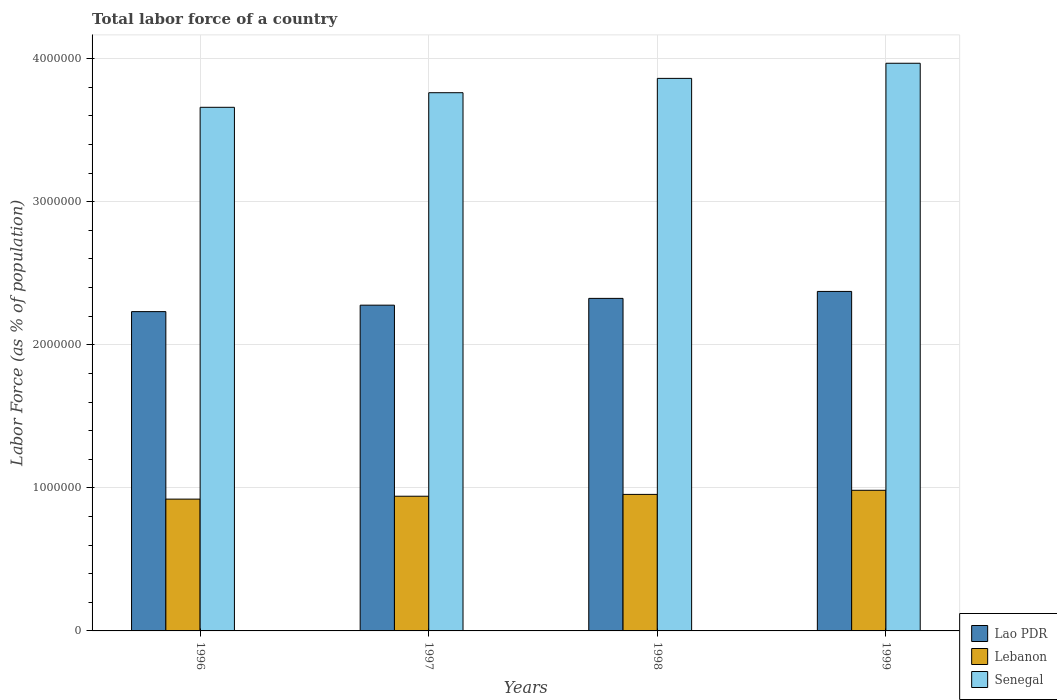How many different coloured bars are there?
Offer a very short reply. 3. How many groups of bars are there?
Offer a terse response. 4. Are the number of bars per tick equal to the number of legend labels?
Offer a very short reply. Yes. Are the number of bars on each tick of the X-axis equal?
Your answer should be very brief. Yes. How many bars are there on the 2nd tick from the right?
Give a very brief answer. 3. What is the label of the 4th group of bars from the left?
Keep it short and to the point. 1999. In how many cases, is the number of bars for a given year not equal to the number of legend labels?
Ensure brevity in your answer.  0. What is the percentage of labor force in Lebanon in 1997?
Give a very brief answer. 9.42e+05. Across all years, what is the maximum percentage of labor force in Lao PDR?
Your response must be concise. 2.37e+06. Across all years, what is the minimum percentage of labor force in Senegal?
Offer a terse response. 3.66e+06. In which year was the percentage of labor force in Lao PDR minimum?
Your response must be concise. 1996. What is the total percentage of labor force in Senegal in the graph?
Your answer should be compact. 1.53e+07. What is the difference between the percentage of labor force in Lebanon in 1996 and that in 1999?
Your answer should be very brief. -6.17e+04. What is the difference between the percentage of labor force in Senegal in 1998 and the percentage of labor force in Lao PDR in 1996?
Make the answer very short. 1.63e+06. What is the average percentage of labor force in Lao PDR per year?
Offer a very short reply. 2.30e+06. In the year 1997, what is the difference between the percentage of labor force in Lebanon and percentage of labor force in Lao PDR?
Ensure brevity in your answer.  -1.34e+06. What is the ratio of the percentage of labor force in Lebanon in 1997 to that in 1998?
Ensure brevity in your answer.  0.99. Is the difference between the percentage of labor force in Lebanon in 1997 and 1998 greater than the difference between the percentage of labor force in Lao PDR in 1997 and 1998?
Offer a terse response. Yes. What is the difference between the highest and the second highest percentage of labor force in Senegal?
Provide a succinct answer. 1.06e+05. What is the difference between the highest and the lowest percentage of labor force in Lebanon?
Provide a short and direct response. 6.17e+04. What does the 2nd bar from the left in 1996 represents?
Your answer should be very brief. Lebanon. What does the 3rd bar from the right in 1996 represents?
Give a very brief answer. Lao PDR. How many bars are there?
Your response must be concise. 12. Are all the bars in the graph horizontal?
Give a very brief answer. No. What is the difference between two consecutive major ticks on the Y-axis?
Offer a terse response. 1.00e+06. Are the values on the major ticks of Y-axis written in scientific E-notation?
Offer a very short reply. No. Does the graph contain any zero values?
Make the answer very short. No. Does the graph contain grids?
Provide a short and direct response. Yes. How many legend labels are there?
Ensure brevity in your answer.  3. What is the title of the graph?
Provide a short and direct response. Total labor force of a country. What is the label or title of the Y-axis?
Ensure brevity in your answer.  Labor Force (as % of population). What is the Labor Force (as % of population) of Lao PDR in 1996?
Ensure brevity in your answer.  2.23e+06. What is the Labor Force (as % of population) in Lebanon in 1996?
Offer a very short reply. 9.21e+05. What is the Labor Force (as % of population) of Senegal in 1996?
Your answer should be very brief. 3.66e+06. What is the Labor Force (as % of population) of Lao PDR in 1997?
Give a very brief answer. 2.28e+06. What is the Labor Force (as % of population) of Lebanon in 1997?
Your answer should be compact. 9.42e+05. What is the Labor Force (as % of population) in Senegal in 1997?
Your answer should be very brief. 3.76e+06. What is the Labor Force (as % of population) of Lao PDR in 1998?
Your answer should be compact. 2.32e+06. What is the Labor Force (as % of population) in Lebanon in 1998?
Your response must be concise. 9.54e+05. What is the Labor Force (as % of population) of Senegal in 1998?
Provide a short and direct response. 3.86e+06. What is the Labor Force (as % of population) of Lao PDR in 1999?
Your answer should be very brief. 2.37e+06. What is the Labor Force (as % of population) in Lebanon in 1999?
Your answer should be compact. 9.83e+05. What is the Labor Force (as % of population) of Senegal in 1999?
Your answer should be very brief. 3.97e+06. Across all years, what is the maximum Labor Force (as % of population) in Lao PDR?
Provide a succinct answer. 2.37e+06. Across all years, what is the maximum Labor Force (as % of population) of Lebanon?
Offer a terse response. 9.83e+05. Across all years, what is the maximum Labor Force (as % of population) in Senegal?
Offer a very short reply. 3.97e+06. Across all years, what is the minimum Labor Force (as % of population) in Lao PDR?
Your response must be concise. 2.23e+06. Across all years, what is the minimum Labor Force (as % of population) in Lebanon?
Your answer should be very brief. 9.21e+05. Across all years, what is the minimum Labor Force (as % of population) of Senegal?
Make the answer very short. 3.66e+06. What is the total Labor Force (as % of population) in Lao PDR in the graph?
Your answer should be compact. 9.21e+06. What is the total Labor Force (as % of population) of Lebanon in the graph?
Provide a succinct answer. 3.80e+06. What is the total Labor Force (as % of population) in Senegal in the graph?
Provide a short and direct response. 1.53e+07. What is the difference between the Labor Force (as % of population) of Lao PDR in 1996 and that in 1997?
Provide a succinct answer. -4.51e+04. What is the difference between the Labor Force (as % of population) in Lebanon in 1996 and that in 1997?
Offer a terse response. -2.01e+04. What is the difference between the Labor Force (as % of population) of Senegal in 1996 and that in 1997?
Your response must be concise. -1.02e+05. What is the difference between the Labor Force (as % of population) in Lao PDR in 1996 and that in 1998?
Your answer should be very brief. -9.25e+04. What is the difference between the Labor Force (as % of population) of Lebanon in 1996 and that in 1998?
Ensure brevity in your answer.  -3.30e+04. What is the difference between the Labor Force (as % of population) of Senegal in 1996 and that in 1998?
Offer a terse response. -2.02e+05. What is the difference between the Labor Force (as % of population) of Lao PDR in 1996 and that in 1999?
Offer a very short reply. -1.41e+05. What is the difference between the Labor Force (as % of population) in Lebanon in 1996 and that in 1999?
Give a very brief answer. -6.17e+04. What is the difference between the Labor Force (as % of population) of Senegal in 1996 and that in 1999?
Give a very brief answer. -3.08e+05. What is the difference between the Labor Force (as % of population) in Lao PDR in 1997 and that in 1998?
Give a very brief answer. -4.74e+04. What is the difference between the Labor Force (as % of population) in Lebanon in 1997 and that in 1998?
Your response must be concise. -1.28e+04. What is the difference between the Labor Force (as % of population) of Senegal in 1997 and that in 1998?
Ensure brevity in your answer.  -1.00e+05. What is the difference between the Labor Force (as % of population) of Lao PDR in 1997 and that in 1999?
Offer a terse response. -9.60e+04. What is the difference between the Labor Force (as % of population) in Lebanon in 1997 and that in 1999?
Offer a very short reply. -4.16e+04. What is the difference between the Labor Force (as % of population) of Senegal in 1997 and that in 1999?
Provide a short and direct response. -2.06e+05. What is the difference between the Labor Force (as % of population) in Lao PDR in 1998 and that in 1999?
Offer a very short reply. -4.86e+04. What is the difference between the Labor Force (as % of population) of Lebanon in 1998 and that in 1999?
Offer a very short reply. -2.87e+04. What is the difference between the Labor Force (as % of population) of Senegal in 1998 and that in 1999?
Your answer should be compact. -1.06e+05. What is the difference between the Labor Force (as % of population) in Lao PDR in 1996 and the Labor Force (as % of population) in Lebanon in 1997?
Give a very brief answer. 1.29e+06. What is the difference between the Labor Force (as % of population) of Lao PDR in 1996 and the Labor Force (as % of population) of Senegal in 1997?
Your answer should be compact. -1.53e+06. What is the difference between the Labor Force (as % of population) in Lebanon in 1996 and the Labor Force (as % of population) in Senegal in 1997?
Ensure brevity in your answer.  -2.84e+06. What is the difference between the Labor Force (as % of population) of Lao PDR in 1996 and the Labor Force (as % of population) of Lebanon in 1998?
Give a very brief answer. 1.28e+06. What is the difference between the Labor Force (as % of population) of Lao PDR in 1996 and the Labor Force (as % of population) of Senegal in 1998?
Ensure brevity in your answer.  -1.63e+06. What is the difference between the Labor Force (as % of population) of Lebanon in 1996 and the Labor Force (as % of population) of Senegal in 1998?
Offer a very short reply. -2.94e+06. What is the difference between the Labor Force (as % of population) in Lao PDR in 1996 and the Labor Force (as % of population) in Lebanon in 1999?
Your response must be concise. 1.25e+06. What is the difference between the Labor Force (as % of population) of Lao PDR in 1996 and the Labor Force (as % of population) of Senegal in 1999?
Offer a terse response. -1.74e+06. What is the difference between the Labor Force (as % of population) in Lebanon in 1996 and the Labor Force (as % of population) in Senegal in 1999?
Offer a terse response. -3.05e+06. What is the difference between the Labor Force (as % of population) of Lao PDR in 1997 and the Labor Force (as % of population) of Lebanon in 1998?
Offer a very short reply. 1.32e+06. What is the difference between the Labor Force (as % of population) of Lao PDR in 1997 and the Labor Force (as % of population) of Senegal in 1998?
Your answer should be compact. -1.59e+06. What is the difference between the Labor Force (as % of population) of Lebanon in 1997 and the Labor Force (as % of population) of Senegal in 1998?
Make the answer very short. -2.92e+06. What is the difference between the Labor Force (as % of population) in Lao PDR in 1997 and the Labor Force (as % of population) in Lebanon in 1999?
Your answer should be very brief. 1.29e+06. What is the difference between the Labor Force (as % of population) in Lao PDR in 1997 and the Labor Force (as % of population) in Senegal in 1999?
Your response must be concise. -1.69e+06. What is the difference between the Labor Force (as % of population) of Lebanon in 1997 and the Labor Force (as % of population) of Senegal in 1999?
Your response must be concise. -3.03e+06. What is the difference between the Labor Force (as % of population) of Lao PDR in 1998 and the Labor Force (as % of population) of Lebanon in 1999?
Keep it short and to the point. 1.34e+06. What is the difference between the Labor Force (as % of population) in Lao PDR in 1998 and the Labor Force (as % of population) in Senegal in 1999?
Your answer should be very brief. -1.64e+06. What is the difference between the Labor Force (as % of population) in Lebanon in 1998 and the Labor Force (as % of population) in Senegal in 1999?
Offer a terse response. -3.01e+06. What is the average Labor Force (as % of population) of Lao PDR per year?
Offer a terse response. 2.30e+06. What is the average Labor Force (as % of population) of Lebanon per year?
Provide a short and direct response. 9.50e+05. What is the average Labor Force (as % of population) in Senegal per year?
Keep it short and to the point. 3.81e+06. In the year 1996, what is the difference between the Labor Force (as % of population) of Lao PDR and Labor Force (as % of population) of Lebanon?
Keep it short and to the point. 1.31e+06. In the year 1996, what is the difference between the Labor Force (as % of population) in Lao PDR and Labor Force (as % of population) in Senegal?
Keep it short and to the point. -1.43e+06. In the year 1996, what is the difference between the Labor Force (as % of population) in Lebanon and Labor Force (as % of population) in Senegal?
Provide a short and direct response. -2.74e+06. In the year 1997, what is the difference between the Labor Force (as % of population) in Lao PDR and Labor Force (as % of population) in Lebanon?
Make the answer very short. 1.34e+06. In the year 1997, what is the difference between the Labor Force (as % of population) in Lao PDR and Labor Force (as % of population) in Senegal?
Your answer should be very brief. -1.49e+06. In the year 1997, what is the difference between the Labor Force (as % of population) of Lebanon and Labor Force (as % of population) of Senegal?
Keep it short and to the point. -2.82e+06. In the year 1998, what is the difference between the Labor Force (as % of population) of Lao PDR and Labor Force (as % of population) of Lebanon?
Make the answer very short. 1.37e+06. In the year 1998, what is the difference between the Labor Force (as % of population) in Lao PDR and Labor Force (as % of population) in Senegal?
Your answer should be compact. -1.54e+06. In the year 1998, what is the difference between the Labor Force (as % of population) of Lebanon and Labor Force (as % of population) of Senegal?
Your response must be concise. -2.91e+06. In the year 1999, what is the difference between the Labor Force (as % of population) in Lao PDR and Labor Force (as % of population) in Lebanon?
Your answer should be compact. 1.39e+06. In the year 1999, what is the difference between the Labor Force (as % of population) in Lao PDR and Labor Force (as % of population) in Senegal?
Keep it short and to the point. -1.60e+06. In the year 1999, what is the difference between the Labor Force (as % of population) in Lebanon and Labor Force (as % of population) in Senegal?
Ensure brevity in your answer.  -2.99e+06. What is the ratio of the Labor Force (as % of population) in Lao PDR in 1996 to that in 1997?
Provide a short and direct response. 0.98. What is the ratio of the Labor Force (as % of population) of Lebanon in 1996 to that in 1997?
Your answer should be very brief. 0.98. What is the ratio of the Labor Force (as % of population) of Senegal in 1996 to that in 1997?
Offer a very short reply. 0.97. What is the ratio of the Labor Force (as % of population) in Lao PDR in 1996 to that in 1998?
Keep it short and to the point. 0.96. What is the ratio of the Labor Force (as % of population) of Lebanon in 1996 to that in 1998?
Offer a very short reply. 0.97. What is the ratio of the Labor Force (as % of population) in Senegal in 1996 to that in 1998?
Provide a succinct answer. 0.95. What is the ratio of the Labor Force (as % of population) of Lao PDR in 1996 to that in 1999?
Provide a short and direct response. 0.94. What is the ratio of the Labor Force (as % of population) in Lebanon in 1996 to that in 1999?
Your response must be concise. 0.94. What is the ratio of the Labor Force (as % of population) in Senegal in 1996 to that in 1999?
Your answer should be compact. 0.92. What is the ratio of the Labor Force (as % of population) in Lao PDR in 1997 to that in 1998?
Make the answer very short. 0.98. What is the ratio of the Labor Force (as % of population) of Lebanon in 1997 to that in 1998?
Offer a very short reply. 0.99. What is the ratio of the Labor Force (as % of population) in Senegal in 1997 to that in 1998?
Keep it short and to the point. 0.97. What is the ratio of the Labor Force (as % of population) in Lao PDR in 1997 to that in 1999?
Your answer should be very brief. 0.96. What is the ratio of the Labor Force (as % of population) in Lebanon in 1997 to that in 1999?
Provide a succinct answer. 0.96. What is the ratio of the Labor Force (as % of population) in Senegal in 1997 to that in 1999?
Keep it short and to the point. 0.95. What is the ratio of the Labor Force (as % of population) in Lao PDR in 1998 to that in 1999?
Offer a very short reply. 0.98. What is the ratio of the Labor Force (as % of population) of Lebanon in 1998 to that in 1999?
Give a very brief answer. 0.97. What is the ratio of the Labor Force (as % of population) of Senegal in 1998 to that in 1999?
Provide a succinct answer. 0.97. What is the difference between the highest and the second highest Labor Force (as % of population) in Lao PDR?
Your answer should be very brief. 4.86e+04. What is the difference between the highest and the second highest Labor Force (as % of population) in Lebanon?
Provide a succinct answer. 2.87e+04. What is the difference between the highest and the second highest Labor Force (as % of population) of Senegal?
Your answer should be compact. 1.06e+05. What is the difference between the highest and the lowest Labor Force (as % of population) in Lao PDR?
Make the answer very short. 1.41e+05. What is the difference between the highest and the lowest Labor Force (as % of population) in Lebanon?
Provide a succinct answer. 6.17e+04. What is the difference between the highest and the lowest Labor Force (as % of population) of Senegal?
Provide a short and direct response. 3.08e+05. 